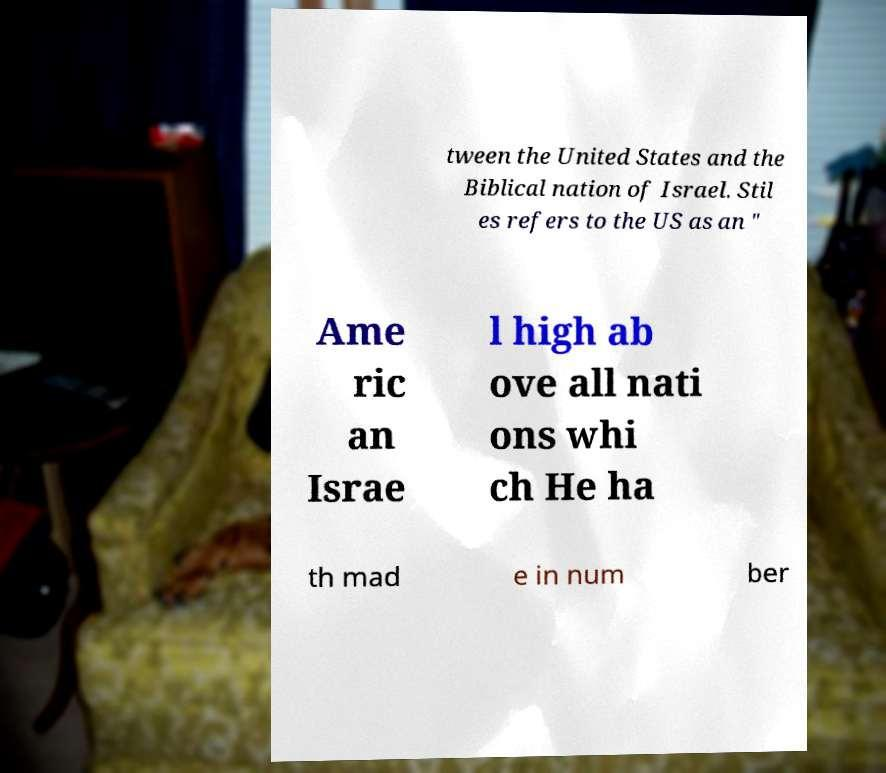Please identify and transcribe the text found in this image. tween the United States and the Biblical nation of Israel. Stil es refers to the US as an " Ame ric an Israe l high ab ove all nati ons whi ch He ha th mad e in num ber 